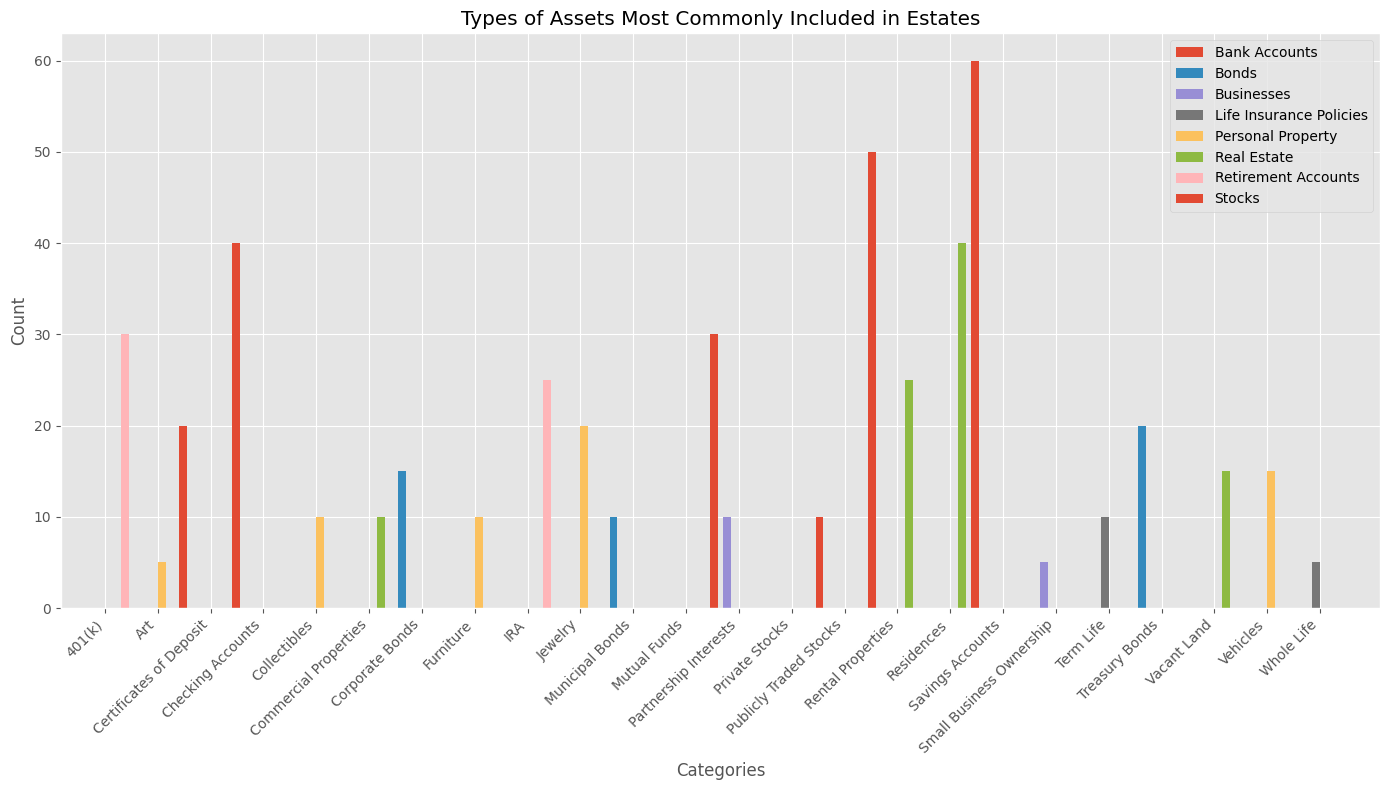Which asset type has the highest count in the 'Real Estate' category? To find the answer, look at the bars corresponding to the 'Real Estate' category. Compare the heights of the bars for each subcategory (Residences, Vacant Land, Commercial Properties, and Rental Properties). The tallest bar represents the subcategory with the highest count.
Answer: Residences How many more publicly traded stocks are there compared to mutual funds in the 'Stocks' category? Identify the number of publicly traded stocks (50) and mutual funds (30) from the bar heights in the 'Stocks' category. Subtract the count of mutual funds from the count of publicly traded stocks. Calculation: 50 - 30 = 20.
Answer: 20 What is the average count of the asset types in the 'Personal Property' category? Add the counts of the subcategories in the 'Personal Property' category: Jewelry (20), Art (5), Vehicles (15), Furniture (10), Collectibles (10). Sum: 20 + 5 + 15 + 10 + 10 = 60. Divide by the number of subcategories: 60 / 5 = 12.
Answer: 12 Which category has a higher count of savings accounts or checking accounts in the 'Bank Accounts' category? Look for the bars associated with savings accounts and checking accounts in the 'Bank Accounts' category. Compare their heights. Savings accounts (60) are taller than checking accounts (40).
Answer: Savings Accounts What is the total count of all types of bonds in the 'Bonds' category? Add the counts of the subcategories in the 'Bonds' category: Corporate Bonds (15), Municipal Bonds (10), Treasury Bonds (20). Sum: 15 + 10 + 20 = 45.
Answer: 45 How does the count of rental properties compare to the count of certificates of deposit? Compare the heights of the bars corresponding to rental properties (Real Estate) and certificates of deposit (Bank Accounts). Rental properties (25) are higher than certificates of deposit (20).
Answer: Rental properties have more Which has fewer counts, term life insurance or vehicles in the 'Personal Property' category? Find the bars for term life insurance (Life Insurance Policies) and vehicles (Personal Property). Compare their heights visually. Term life (10) is shorter than vehicles (15).
Answer: Term Life Insurance By how much do the counts of 401(k) and IRA accounts in the 'Retirement Accounts' category differ? Find the heights of the bars for 401(k) (30) and IRA (25) in the 'Retirement Accounts' category. Subtract the smaller number from the larger number: 30 - 25 = 5.
Answer: 5 Which subcategory has the smallest count in the 'Businesses' category? Look at the bars in the 'Businesses' category. Compare their heights to identify the smallest. Small Business Ownership (5) is shorter than Partnership Interests (10).
Answer: Small Business Ownership 